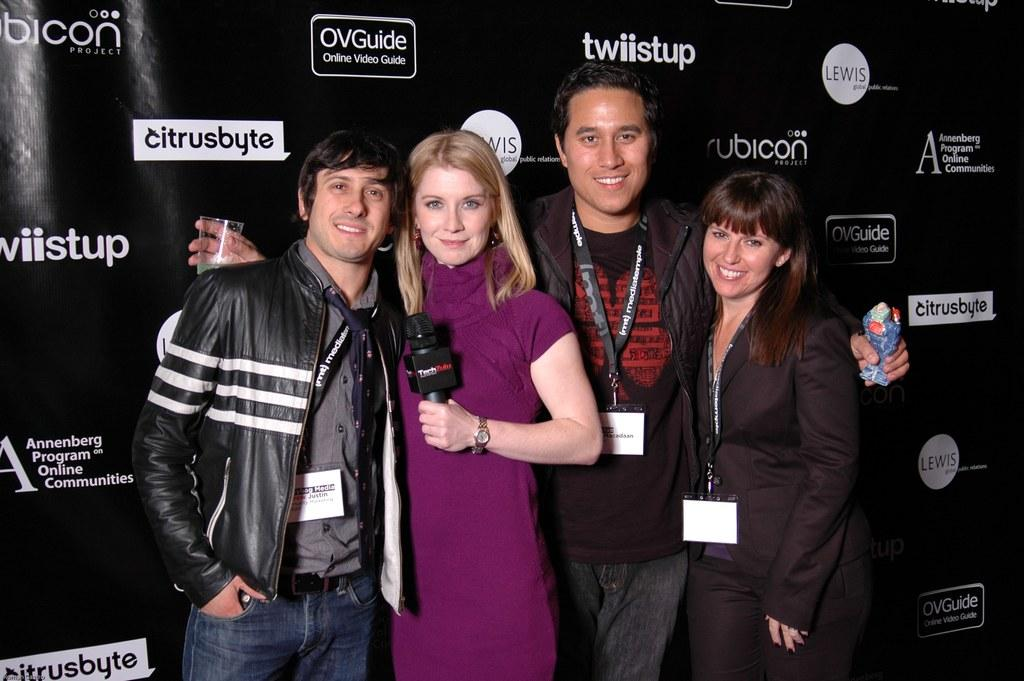<image>
Render a clear and concise summary of the photo. Two women and two men stand for a photo in front of a black backdrop that says "twiistup" and "citrusbyte." 